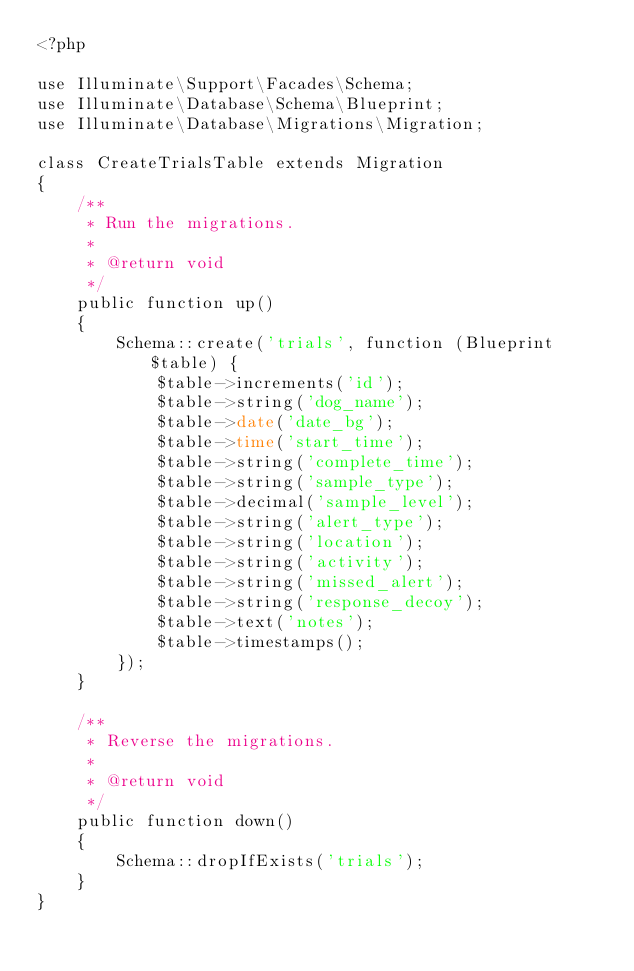<code> <loc_0><loc_0><loc_500><loc_500><_PHP_><?php

use Illuminate\Support\Facades\Schema;
use Illuminate\Database\Schema\Blueprint;
use Illuminate\Database\Migrations\Migration;

class CreateTrialsTable extends Migration
{
    /**
     * Run the migrations.
     *
     * @return void
     */
    public function up()
    {
        Schema::create('trials', function (Blueprint $table) {
            $table->increments('id');
            $table->string('dog_name');
            $table->date('date_bg');
            $table->time('start_time');
            $table->string('complete_time');
            $table->string('sample_type');
            $table->decimal('sample_level');
            $table->string('alert_type');
            $table->string('location');
            $table->string('activity');
            $table->string('missed_alert');
            $table->string('response_decoy');
            $table->text('notes');
            $table->timestamps();
        });
    }

    /**
     * Reverse the migrations.
     *
     * @return void
     */
    public function down()
    {
        Schema::dropIfExists('trials');
    }
}
</code> 